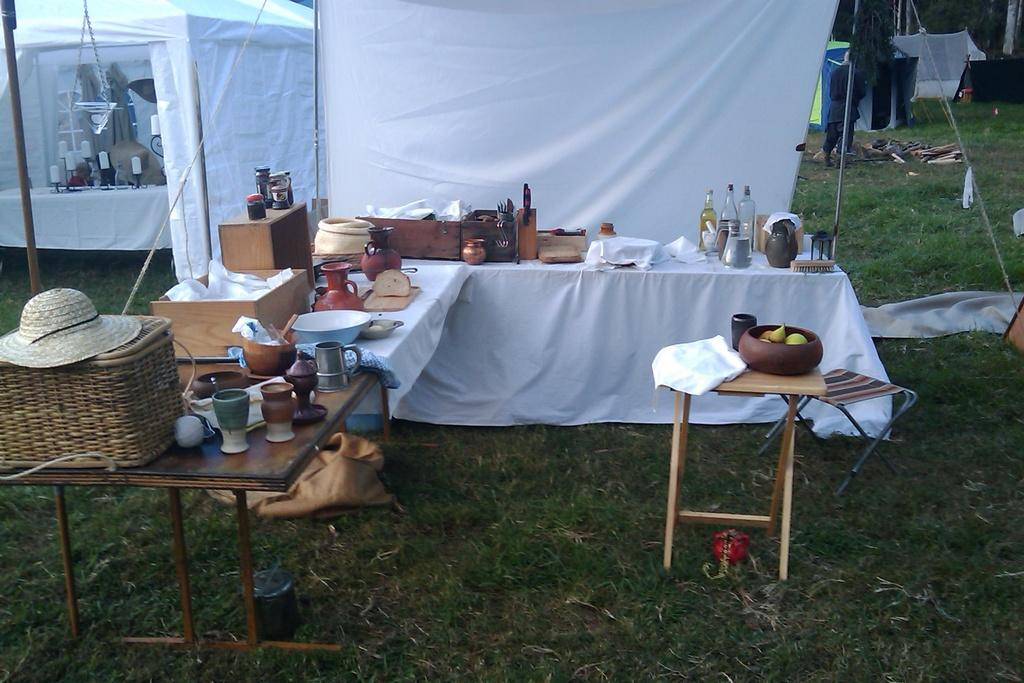What type of container is visible in the image? There is a glass bottle in the image. What material is the cloth made of in the image? The cloth in the image is made of an unspecified material. What can be found on the table in the image? There are other objects on a table in the image, but their specifics are not mentioned. What type of shelter is present in the image? There is a tent in the image. What type of vegetation is visible in the image? There is grass in the image. What type of seating is present in the image? There is a stool in the image. What type of meat is being bitten by the dog in the image? There is no dog or meat present in the image. What decision is being made by the person in the image? There is no person or decision-making process depicted in the image. 